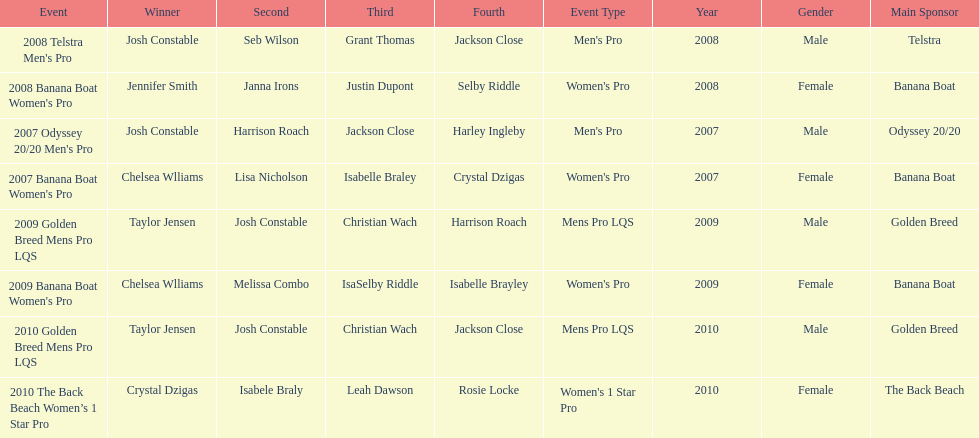How many times did josh constable triumph after 2007? 1. 